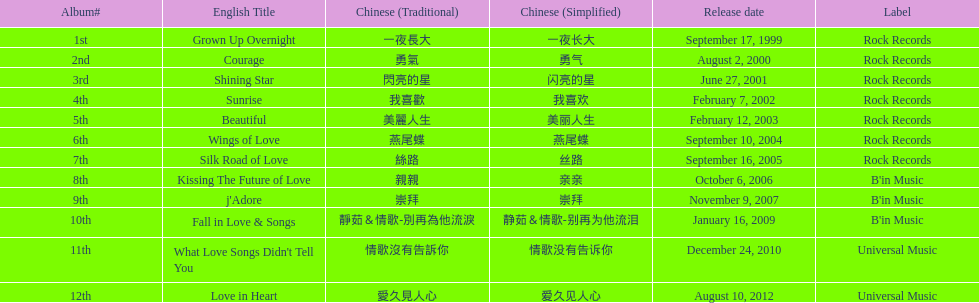Was the album beautiful released before the album love in heart? Yes. 